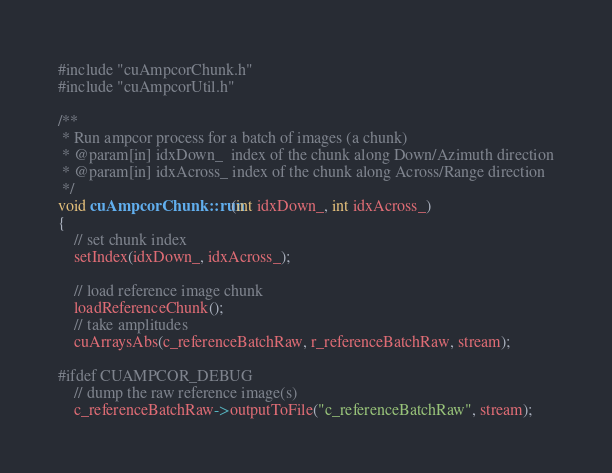<code> <loc_0><loc_0><loc_500><loc_500><_Cuda_>#include "cuAmpcorChunk.h"
#include "cuAmpcorUtil.h"

/**
 * Run ampcor process for a batch of images (a chunk)
 * @param[in] idxDown_  index of the chunk along Down/Azimuth direction
 * @param[in] idxAcross_ index of the chunk along Across/Range direction
 */
void cuAmpcorChunk::run(int idxDown_, int idxAcross_)
{
    // set chunk index
    setIndex(idxDown_, idxAcross_);

    // load reference image chunk
    loadReferenceChunk();
    // take amplitudes
    cuArraysAbs(c_referenceBatchRaw, r_referenceBatchRaw, stream);

#ifdef CUAMPCOR_DEBUG
    // dump the raw reference image(s)
    c_referenceBatchRaw->outputToFile("c_referenceBatchRaw", stream);</code> 